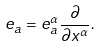<formula> <loc_0><loc_0><loc_500><loc_500>e _ { a } = e ^ { \alpha } _ { a } \frac { \partial } { \partial x ^ { \alpha } } .</formula> 